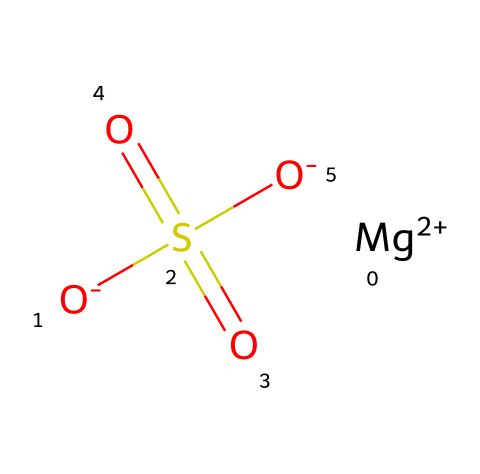What is the molecular formula of magnesium sulfate? The chemical composition indicates one magnesium (Mg), one sulfur (S), and four oxygen (O) atoms, which combine to form the molecular formula MgSO4.
Answer: MgSO4 How many oxygen atoms are present in this compound? Analyzing the structure shows there are four oxygen atoms connected to the sulfur atom (two single and two double bonds).
Answer: four What is the charge on the magnesium ion? The notation in the structure indicates that magnesium is represented as [Mg+2], indicating it has a +2 charge.
Answer: +2 How many sulfate groups are in this molecule? The structure shows that there is one sulfate moiety (the group containing sulfur and oxygen), represented by the SO4 unit.
Answer: one What type of electrolyte is magnesium sulfate considered? Magnesium sulfate is classified as a nonelectrolyte due to its dissociation in solution forming magnesium and sulfate ions but having no significant conductivity in solid state.
Answer: nonelectrolyte How does magnesium sulfate affect the body when used in baths? Magnesium sulfate can be absorbed through the skin and can help relax muscles and relieve stress, providing therapeutic effects in bath applications.
Answer: relaxes muscles 